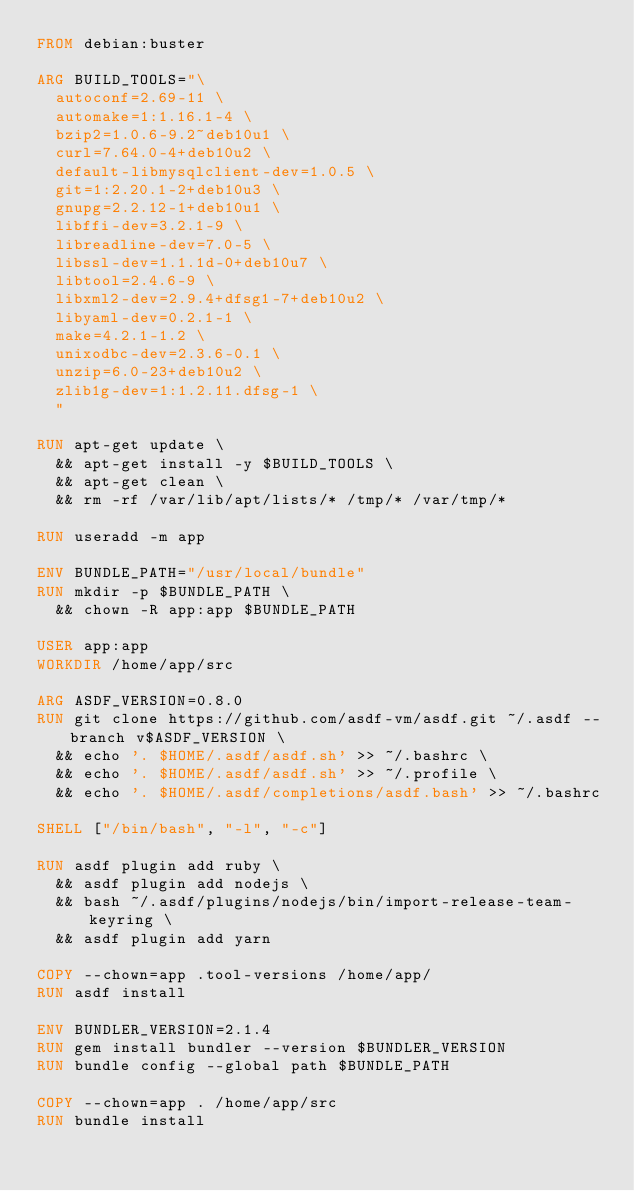Convert code to text. <code><loc_0><loc_0><loc_500><loc_500><_Dockerfile_>FROM debian:buster

ARG BUILD_TOOLS="\
  autoconf=2.69-11 \
  automake=1:1.16.1-4 \
  bzip2=1.0.6-9.2~deb10u1 \
  curl=7.64.0-4+deb10u2 \
  default-libmysqlclient-dev=1.0.5 \
  git=1:2.20.1-2+deb10u3 \
  gnupg=2.2.12-1+deb10u1 \
  libffi-dev=3.2.1-9 \
  libreadline-dev=7.0-5 \
  libssl-dev=1.1.1d-0+deb10u7 \
  libtool=2.4.6-9 \
  libxml2-dev=2.9.4+dfsg1-7+deb10u2 \
  libyaml-dev=0.2.1-1 \
  make=4.2.1-1.2 \
  unixodbc-dev=2.3.6-0.1 \
  unzip=6.0-23+deb10u2 \
  zlib1g-dev=1:1.2.11.dfsg-1 \
  "

RUN apt-get update \
  && apt-get install -y $BUILD_TOOLS \
  && apt-get clean \
  && rm -rf /var/lib/apt/lists/* /tmp/* /var/tmp/*

RUN useradd -m app

ENV BUNDLE_PATH="/usr/local/bundle"
RUN mkdir -p $BUNDLE_PATH \
  && chown -R app:app $BUNDLE_PATH

USER app:app
WORKDIR /home/app/src

ARG ASDF_VERSION=0.8.0
RUN git clone https://github.com/asdf-vm/asdf.git ~/.asdf --branch v$ASDF_VERSION \
  && echo '. $HOME/.asdf/asdf.sh' >> ~/.bashrc \
  && echo '. $HOME/.asdf/asdf.sh' >> ~/.profile \
  && echo '. $HOME/.asdf/completions/asdf.bash' >> ~/.bashrc

SHELL ["/bin/bash", "-l", "-c"]

RUN asdf plugin add ruby \
  && asdf plugin add nodejs \
  && bash ~/.asdf/plugins/nodejs/bin/import-release-team-keyring \
  && asdf plugin add yarn

COPY --chown=app .tool-versions /home/app/
RUN asdf install

ENV BUNDLER_VERSION=2.1.4
RUN gem install bundler --version $BUNDLER_VERSION
RUN bundle config --global path $BUNDLE_PATH

COPY --chown=app . /home/app/src
RUN bundle install
</code> 